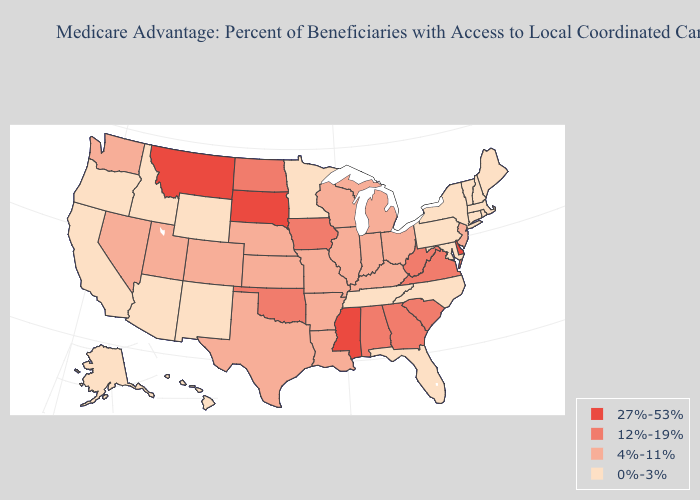Among the states that border South Carolina , which have the highest value?
Answer briefly. Georgia. What is the value of Wisconsin?
Concise answer only. 4%-11%. Does Oklahoma have the lowest value in the USA?
Be succinct. No. Among the states that border Alabama , which have the lowest value?
Quick response, please. Florida, Tennessee. What is the value of Indiana?
Answer briefly. 4%-11%. What is the value of Indiana?
Answer briefly. 4%-11%. What is the highest value in states that border Florida?
Give a very brief answer. 12%-19%. Which states have the lowest value in the MidWest?
Be succinct. Minnesota. Does Nevada have the lowest value in the West?
Be succinct. No. Does Nebraska have the highest value in the USA?
Quick response, please. No. Does Rhode Island have a higher value than West Virginia?
Concise answer only. No. What is the value of Indiana?
Short answer required. 4%-11%. Name the states that have a value in the range 0%-3%?
Give a very brief answer. Alaska, Arizona, California, Connecticut, Florida, Hawaii, Idaho, Massachusetts, Maryland, Maine, Minnesota, North Carolina, New Hampshire, New Mexico, New York, Oregon, Pennsylvania, Rhode Island, Tennessee, Vermont, Wyoming. What is the lowest value in the USA?
Concise answer only. 0%-3%. What is the value of Nebraska?
Concise answer only. 4%-11%. 